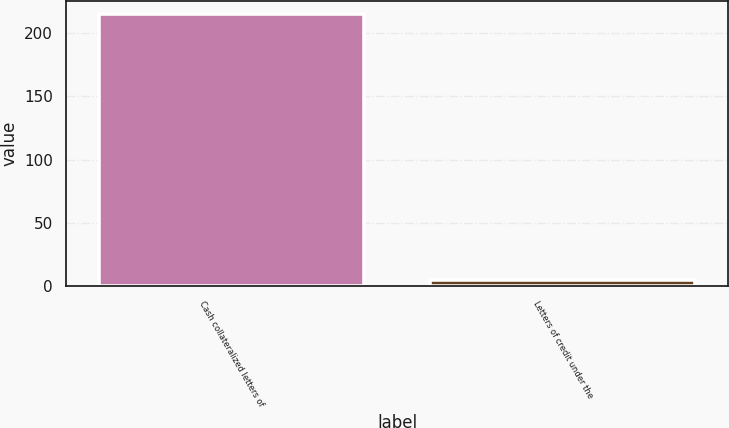Convert chart to OTSL. <chart><loc_0><loc_0><loc_500><loc_500><bar_chart><fcel>Cash collateralized letters of<fcel>Letters of credit under the<nl><fcel>215<fcel>5<nl></chart> 